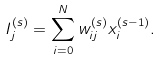<formula> <loc_0><loc_0><loc_500><loc_500>I ^ { ( s ) } _ { j } = \sum _ { i = 0 } ^ { N } w ^ { ( s ) } _ { i j } x ^ { ( s - 1 ) } _ { i } .</formula> 